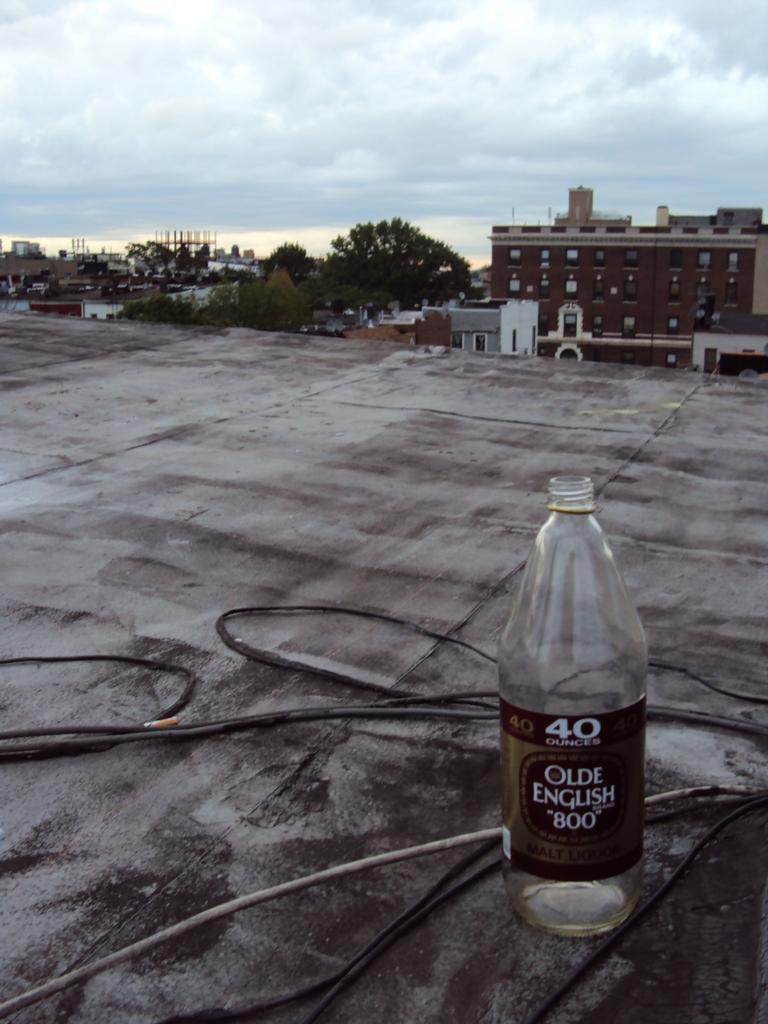<image>
Write a terse but informative summary of the picture. A bottle of Olde English "800" sitting on a rooftop. 